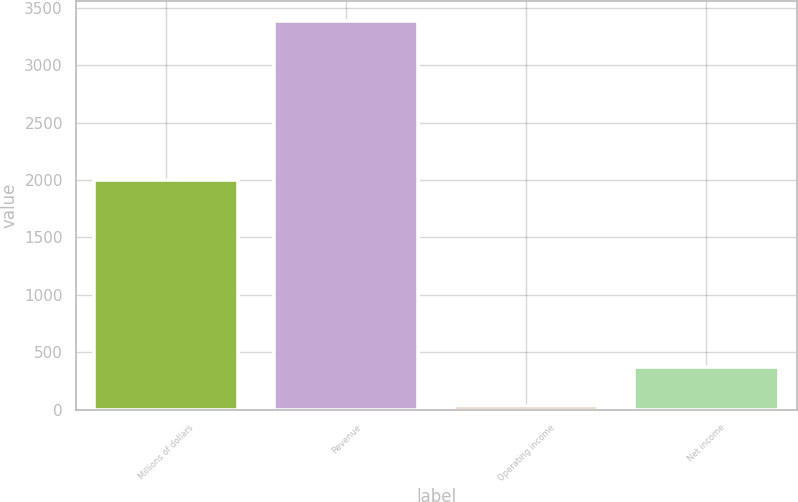Convert chart to OTSL. <chart><loc_0><loc_0><loc_500><loc_500><bar_chart><fcel>Millions of dollars<fcel>Revenue<fcel>Operating income<fcel>Net income<nl><fcel>2004<fcel>3388<fcel>34<fcel>369.4<nl></chart> 